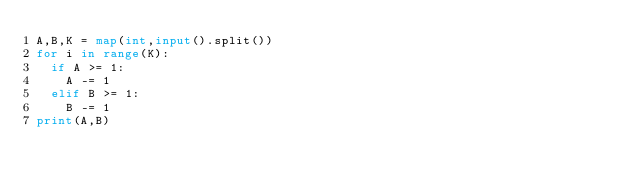Convert code to text. <code><loc_0><loc_0><loc_500><loc_500><_Python_>A,B,K = map(int,input().split())
for i in range(K):
  if A >= 1:
    A -= 1
  elif B >= 1:
    B -= 1
print(A,B)</code> 